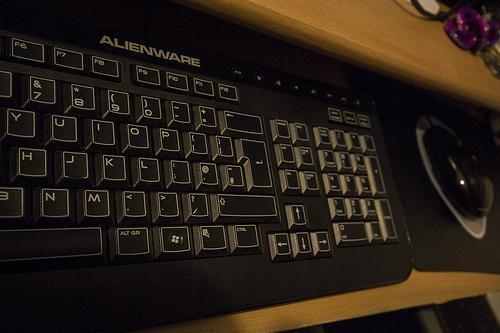How many keyboards are there?
Give a very brief answer. 1. 